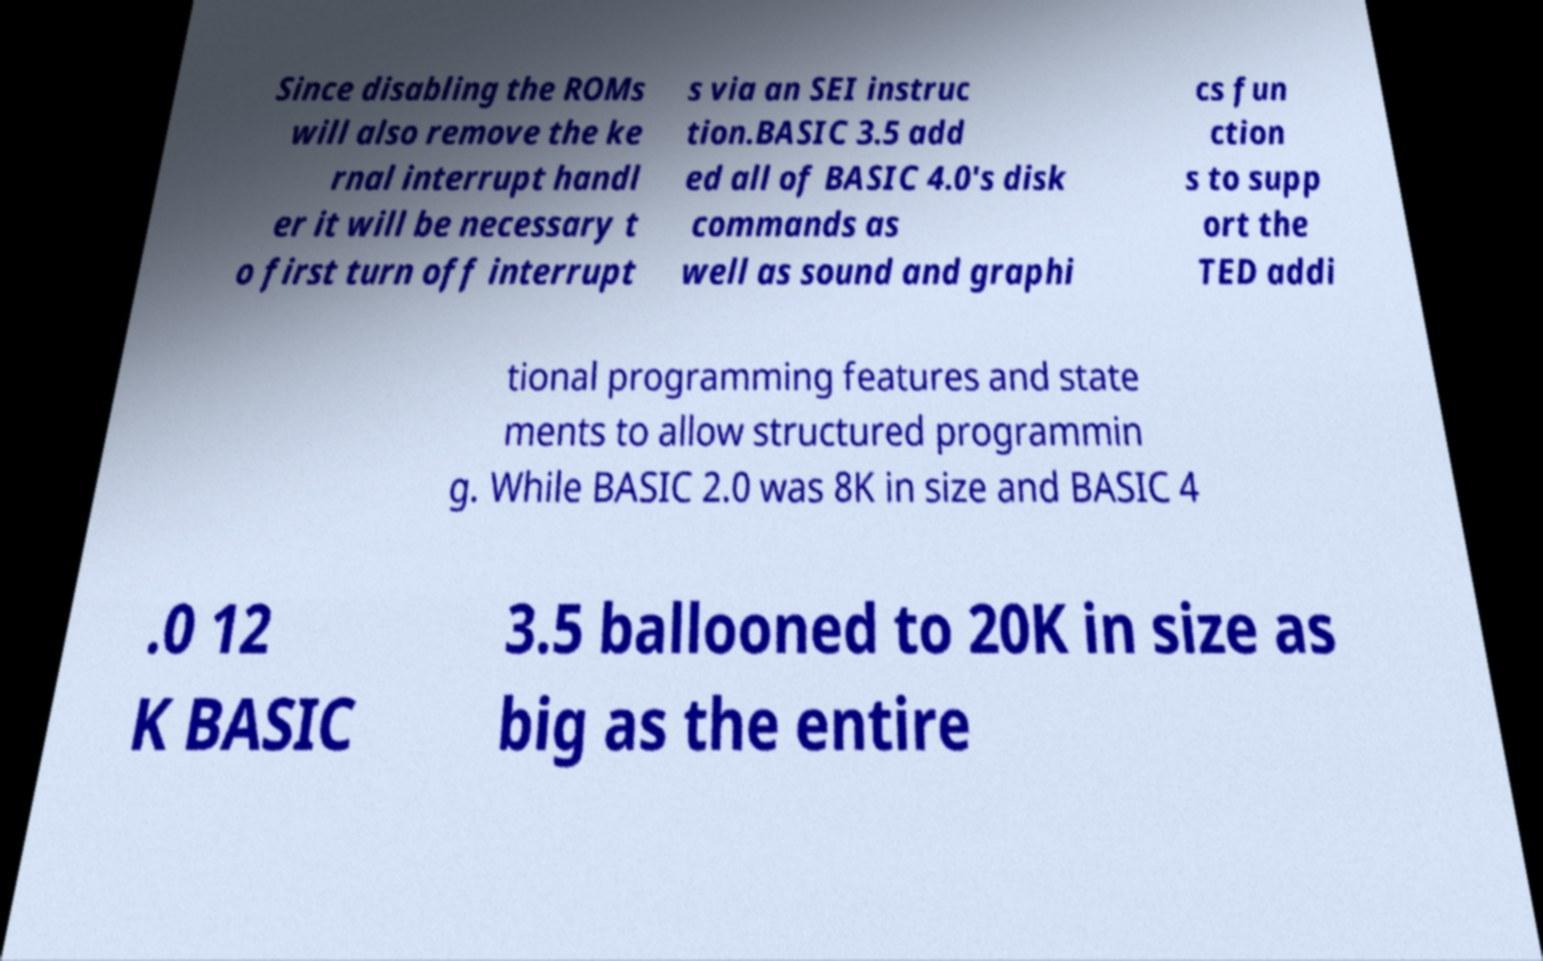I need the written content from this picture converted into text. Can you do that? Since disabling the ROMs will also remove the ke rnal interrupt handl er it will be necessary t o first turn off interrupt s via an SEI instruc tion.BASIC 3.5 add ed all of BASIC 4.0's disk commands as well as sound and graphi cs fun ction s to supp ort the TED addi tional programming features and state ments to allow structured programmin g. While BASIC 2.0 was 8K in size and BASIC 4 .0 12 K BASIC 3.5 ballooned to 20K in size as big as the entire 